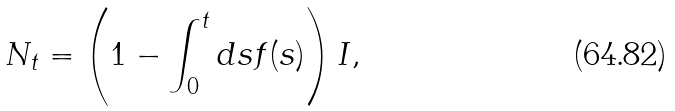<formula> <loc_0><loc_0><loc_500><loc_500>N _ { t } = \left ( 1 - \int _ { 0 } ^ { t } d s f ( s ) \right ) I ,</formula> 